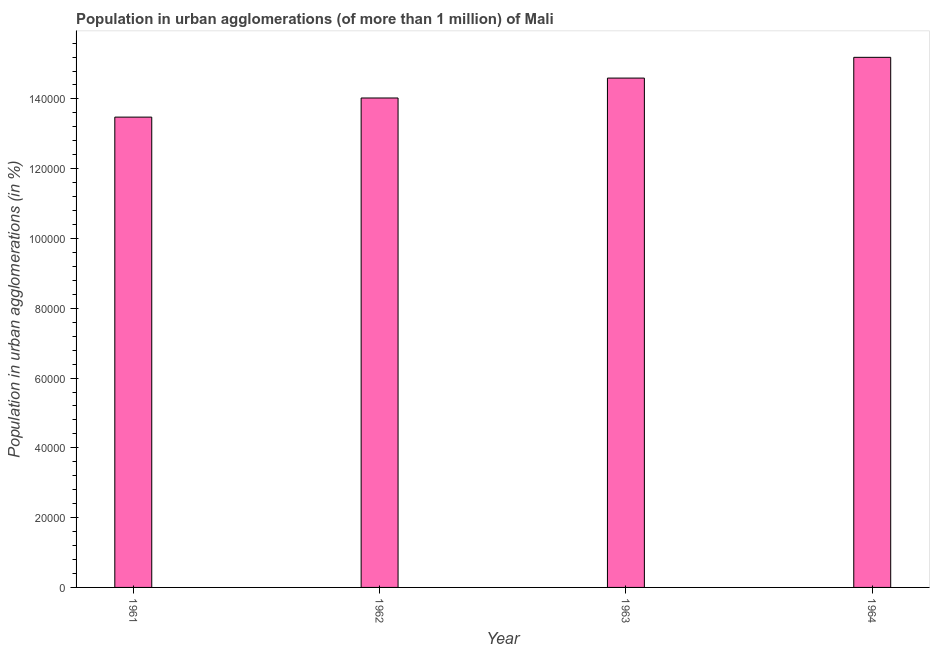Does the graph contain any zero values?
Ensure brevity in your answer.  No. What is the title of the graph?
Make the answer very short. Population in urban agglomerations (of more than 1 million) of Mali. What is the label or title of the Y-axis?
Make the answer very short. Population in urban agglomerations (in %). What is the population in urban agglomerations in 1963?
Make the answer very short. 1.46e+05. Across all years, what is the maximum population in urban agglomerations?
Your answer should be very brief. 1.52e+05. Across all years, what is the minimum population in urban agglomerations?
Offer a terse response. 1.35e+05. In which year was the population in urban agglomerations maximum?
Keep it short and to the point. 1964. In which year was the population in urban agglomerations minimum?
Your response must be concise. 1961. What is the sum of the population in urban agglomerations?
Offer a very short reply. 5.73e+05. What is the difference between the population in urban agglomerations in 1962 and 1964?
Your response must be concise. -1.17e+04. What is the average population in urban agglomerations per year?
Give a very brief answer. 1.43e+05. What is the median population in urban agglomerations?
Provide a short and direct response. 1.43e+05. In how many years, is the population in urban agglomerations greater than 4000 %?
Your answer should be very brief. 4. Do a majority of the years between 1964 and 1961 (inclusive) have population in urban agglomerations greater than 152000 %?
Give a very brief answer. Yes. What is the ratio of the population in urban agglomerations in 1962 to that in 1964?
Offer a very short reply. 0.92. Is the population in urban agglomerations in 1961 less than that in 1962?
Offer a very short reply. Yes. What is the difference between the highest and the second highest population in urban agglomerations?
Your answer should be compact. 5947. What is the difference between the highest and the lowest population in urban agglomerations?
Offer a very short reply. 1.71e+04. How many years are there in the graph?
Provide a succinct answer. 4. What is the difference between two consecutive major ticks on the Y-axis?
Make the answer very short. 2.00e+04. What is the Population in urban agglomerations (in %) in 1961?
Your response must be concise. 1.35e+05. What is the Population in urban agglomerations (in %) of 1962?
Offer a terse response. 1.40e+05. What is the Population in urban agglomerations (in %) of 1963?
Offer a terse response. 1.46e+05. What is the Population in urban agglomerations (in %) of 1964?
Ensure brevity in your answer.  1.52e+05. What is the difference between the Population in urban agglomerations (in %) in 1961 and 1962?
Make the answer very short. -5483. What is the difference between the Population in urban agglomerations (in %) in 1961 and 1963?
Your answer should be compact. -1.12e+04. What is the difference between the Population in urban agglomerations (in %) in 1961 and 1964?
Provide a succinct answer. -1.71e+04. What is the difference between the Population in urban agglomerations (in %) in 1962 and 1963?
Offer a very short reply. -5706. What is the difference between the Population in urban agglomerations (in %) in 1962 and 1964?
Offer a terse response. -1.17e+04. What is the difference between the Population in urban agglomerations (in %) in 1963 and 1964?
Provide a succinct answer. -5947. What is the ratio of the Population in urban agglomerations (in %) in 1961 to that in 1962?
Offer a terse response. 0.96. What is the ratio of the Population in urban agglomerations (in %) in 1961 to that in 1963?
Provide a short and direct response. 0.92. What is the ratio of the Population in urban agglomerations (in %) in 1961 to that in 1964?
Keep it short and to the point. 0.89. What is the ratio of the Population in urban agglomerations (in %) in 1962 to that in 1964?
Offer a terse response. 0.92. What is the ratio of the Population in urban agglomerations (in %) in 1963 to that in 1964?
Offer a very short reply. 0.96. 